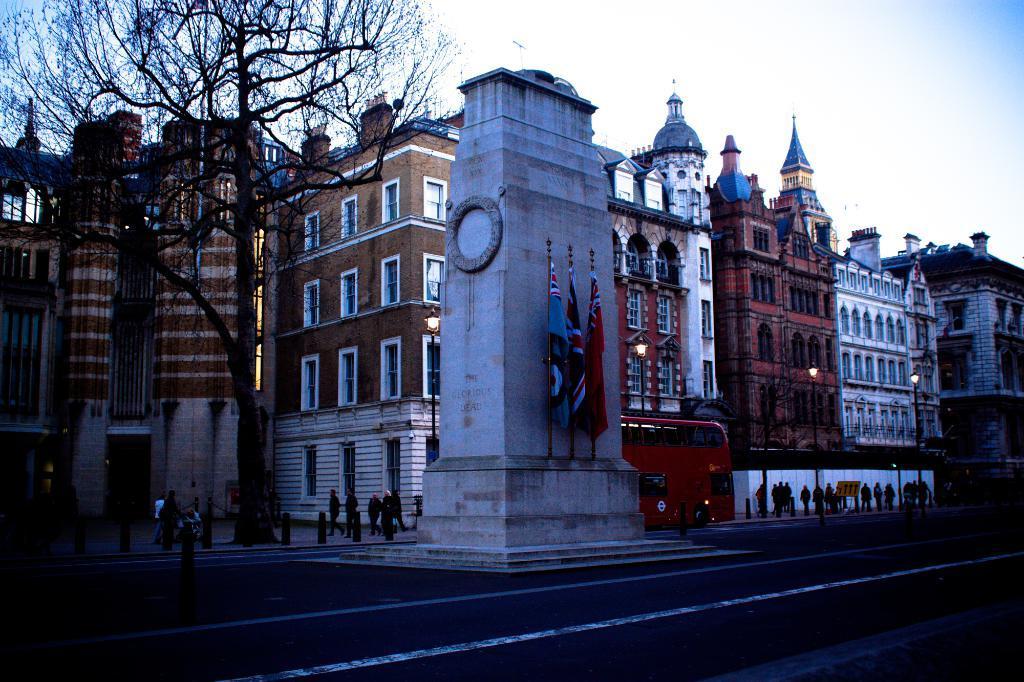Describe this image in one or two sentences. In this image we can see the buildings. We can also see a memorial, tree, bus, flags and also some poles. We can also see a few people walking. At the top there is sky and at the bottom we can see the road. 